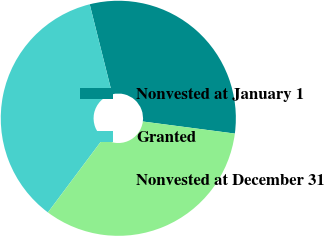Convert chart. <chart><loc_0><loc_0><loc_500><loc_500><pie_chart><fcel>Nonvested at January 1<fcel>Granted<fcel>Nonvested at December 31<nl><fcel>30.99%<fcel>35.87%<fcel>33.14%<nl></chart> 